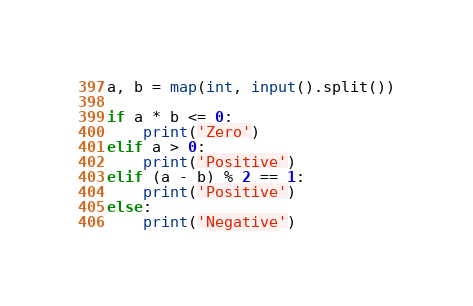Convert code to text. <code><loc_0><loc_0><loc_500><loc_500><_Python_>a, b = map(int, input().split())

if a * b <= 0:
    print('Zero')
elif a > 0:
    print('Positive')
elif (a - b) % 2 == 1:
    print('Positive')
else:
    print('Negative')</code> 